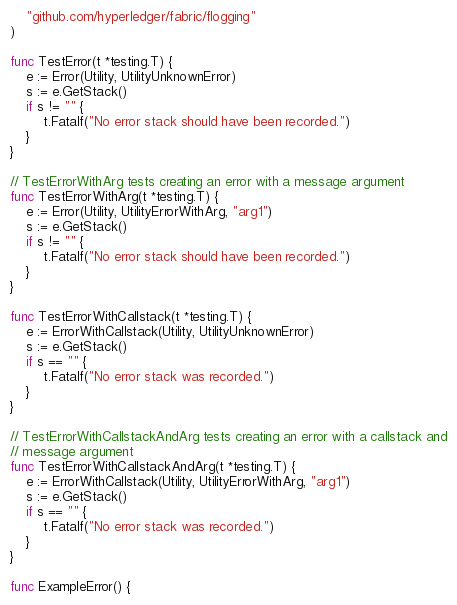Convert code to text. <code><loc_0><loc_0><loc_500><loc_500><_Go_>	"github.com/hyperledger/fabric/flogging"
)

func TestError(t *testing.T) {
	e := Error(Utility, UtilityUnknownError)
	s := e.GetStack()
	if s != "" {
		t.Fatalf("No error stack should have been recorded.")
	}
}

// TestErrorWithArg tests creating an error with a message argument
func TestErrorWithArg(t *testing.T) {
	e := Error(Utility, UtilityErrorWithArg, "arg1")
	s := e.GetStack()
	if s != "" {
		t.Fatalf("No error stack should have been recorded.")
	}
}

func TestErrorWithCallstack(t *testing.T) {
	e := ErrorWithCallstack(Utility, UtilityUnknownError)
	s := e.GetStack()
	if s == "" {
		t.Fatalf("No error stack was recorded.")
	}
}

// TestErrorWithCallstackAndArg tests creating an error with a callstack and
// message argument
func TestErrorWithCallstackAndArg(t *testing.T) {
	e := ErrorWithCallstack(Utility, UtilityErrorWithArg, "arg1")
	s := e.GetStack()
	if s == "" {
		t.Fatalf("No error stack was recorded.")
	}
}

func ExampleError() {</code> 